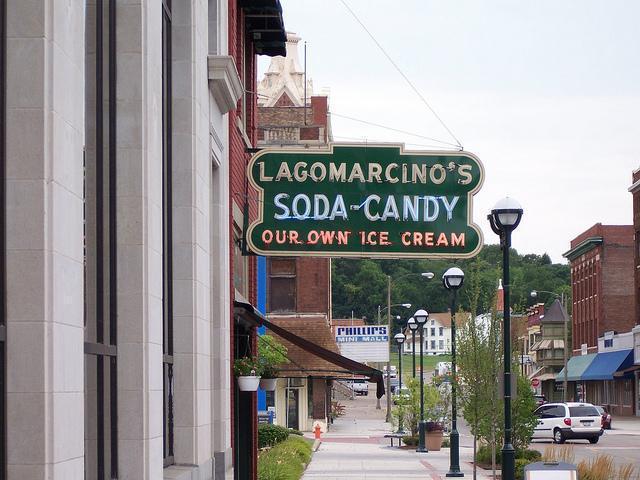What product is made at and for Lagomarcino's?
Make your selection and explain in format: 'Answer: answer
Rationale: rationale.'
Options: Wallets, wendy's shakes, ice cream, none. Answer: ice cream.
Rationale: The sign clearly states the product. these types of signs are common on store fronts. 